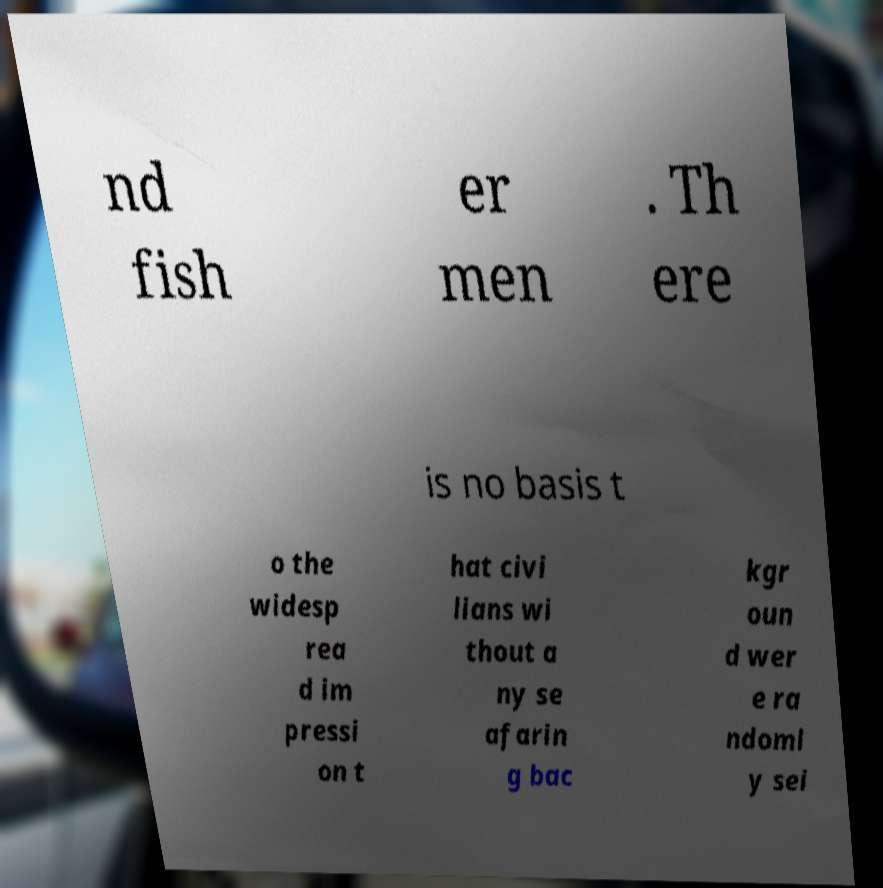Can you accurately transcribe the text from the provided image for me? nd fish er men . Th ere is no basis t o the widesp rea d im pressi on t hat civi lians wi thout a ny se afarin g bac kgr oun d wer e ra ndoml y sei 